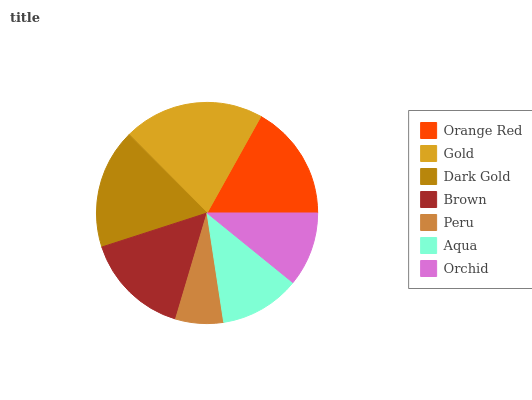Is Peru the minimum?
Answer yes or no. Yes. Is Gold the maximum?
Answer yes or no. Yes. Is Dark Gold the minimum?
Answer yes or no. No. Is Dark Gold the maximum?
Answer yes or no. No. Is Gold greater than Dark Gold?
Answer yes or no. Yes. Is Dark Gold less than Gold?
Answer yes or no. Yes. Is Dark Gold greater than Gold?
Answer yes or no. No. Is Gold less than Dark Gold?
Answer yes or no. No. Is Brown the high median?
Answer yes or no. Yes. Is Brown the low median?
Answer yes or no. Yes. Is Orchid the high median?
Answer yes or no. No. Is Dark Gold the low median?
Answer yes or no. No. 